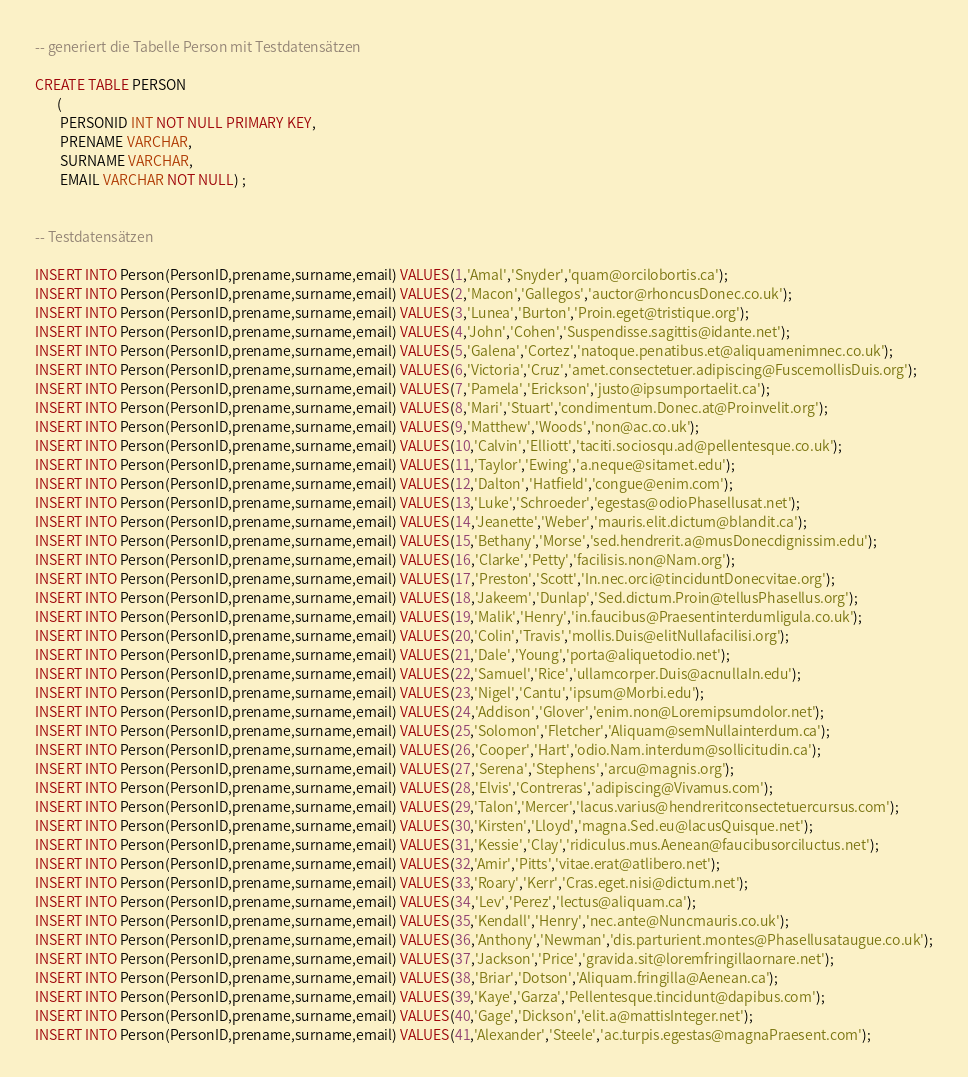Convert code to text. <code><loc_0><loc_0><loc_500><loc_500><_SQL_>-- generiert die Tabelle Person mit Testdatensätzen

CREATE TABLE PERSON
       (
		PERSONID INT NOT NULL PRIMARY KEY,
		PRENAME VARCHAR,
		SURNAME VARCHAR,
		EMAIL VARCHAR NOT NULL) ;
		

-- Testdatensätzen

INSERT INTO Person(PersonID,prename,surname,email) VALUES(1,'Amal','Snyder','quam@orcilobortis.ca');
INSERT INTO Person(PersonID,prename,surname,email) VALUES(2,'Macon','Gallegos','auctor@rhoncusDonec.co.uk');
INSERT INTO Person(PersonID,prename,surname,email) VALUES(3,'Lunea','Burton','Proin.eget@tristique.org');
INSERT INTO Person(PersonID,prename,surname,email) VALUES(4,'John','Cohen','Suspendisse.sagittis@idante.net');
INSERT INTO Person(PersonID,prename,surname,email) VALUES(5,'Galena','Cortez','natoque.penatibus.et@aliquamenimnec.co.uk');
INSERT INTO Person(PersonID,prename,surname,email) VALUES(6,'Victoria','Cruz','amet.consectetuer.adipiscing@FuscemollisDuis.org');
INSERT INTO Person(PersonID,prename,surname,email) VALUES(7,'Pamela','Erickson','justo@ipsumportaelit.ca');
INSERT INTO Person(PersonID,prename,surname,email) VALUES(8,'Mari','Stuart','condimentum.Donec.at@Proinvelit.org');
INSERT INTO Person(PersonID,prename,surname,email) VALUES(9,'Matthew','Woods','non@ac.co.uk');
INSERT INTO Person(PersonID,prename,surname,email) VALUES(10,'Calvin','Elliott','taciti.sociosqu.ad@pellentesque.co.uk');
INSERT INTO Person(PersonID,prename,surname,email) VALUES(11,'Taylor','Ewing','a.neque@sitamet.edu');
INSERT INTO Person(PersonID,prename,surname,email) VALUES(12,'Dalton','Hatfield','congue@enim.com');
INSERT INTO Person(PersonID,prename,surname,email) VALUES(13,'Luke','Schroeder','egestas@odioPhasellusat.net');
INSERT INTO Person(PersonID,prename,surname,email) VALUES(14,'Jeanette','Weber','mauris.elit.dictum@blandit.ca');
INSERT INTO Person(PersonID,prename,surname,email) VALUES(15,'Bethany','Morse','sed.hendrerit.a@musDonecdignissim.edu');
INSERT INTO Person(PersonID,prename,surname,email) VALUES(16,'Clarke','Petty','facilisis.non@Nam.org');
INSERT INTO Person(PersonID,prename,surname,email) VALUES(17,'Preston','Scott','In.nec.orci@tinciduntDonecvitae.org');
INSERT INTO Person(PersonID,prename,surname,email) VALUES(18,'Jakeem','Dunlap','Sed.dictum.Proin@tellusPhasellus.org');
INSERT INTO Person(PersonID,prename,surname,email) VALUES(19,'Malik','Henry','in.faucibus@Praesentinterdumligula.co.uk');
INSERT INTO Person(PersonID,prename,surname,email) VALUES(20,'Colin','Travis','mollis.Duis@elitNullafacilisi.org');
INSERT INTO Person(PersonID,prename,surname,email) VALUES(21,'Dale','Young','porta@aliquetodio.net');
INSERT INTO Person(PersonID,prename,surname,email) VALUES(22,'Samuel','Rice','ullamcorper.Duis@acnullaIn.edu');
INSERT INTO Person(PersonID,prename,surname,email) VALUES(23,'Nigel','Cantu','ipsum@Morbi.edu');
INSERT INTO Person(PersonID,prename,surname,email) VALUES(24,'Addison','Glover','enim.non@Loremipsumdolor.net');
INSERT INTO Person(PersonID,prename,surname,email) VALUES(25,'Solomon','Fletcher','Aliquam@semNullainterdum.ca');
INSERT INTO Person(PersonID,prename,surname,email) VALUES(26,'Cooper','Hart','odio.Nam.interdum@sollicitudin.ca');
INSERT INTO Person(PersonID,prename,surname,email) VALUES(27,'Serena','Stephens','arcu@magnis.org');
INSERT INTO Person(PersonID,prename,surname,email) VALUES(28,'Elvis','Contreras','adipiscing@Vivamus.com');
INSERT INTO Person(PersonID,prename,surname,email) VALUES(29,'Talon','Mercer','lacus.varius@hendreritconsectetuercursus.com');
INSERT INTO Person(PersonID,prename,surname,email) VALUES(30,'Kirsten','Lloyd','magna.Sed.eu@lacusQuisque.net');
INSERT INTO Person(PersonID,prename,surname,email) VALUES(31,'Kessie','Clay','ridiculus.mus.Aenean@faucibusorciluctus.net');
INSERT INTO Person(PersonID,prename,surname,email) VALUES(32,'Amir','Pitts','vitae.erat@atlibero.net');
INSERT INTO Person(PersonID,prename,surname,email) VALUES(33,'Roary','Kerr','Cras.eget.nisi@dictum.net');
INSERT INTO Person(PersonID,prename,surname,email) VALUES(34,'Lev','Perez','lectus@aliquam.ca');
INSERT INTO Person(PersonID,prename,surname,email) VALUES(35,'Kendall','Henry','nec.ante@Nuncmauris.co.uk');
INSERT INTO Person(PersonID,prename,surname,email) VALUES(36,'Anthony','Newman','dis.parturient.montes@Phasellusataugue.co.uk');
INSERT INTO Person(PersonID,prename,surname,email) VALUES(37,'Jackson','Price','gravida.sit@loremfringillaornare.net');
INSERT INTO Person(PersonID,prename,surname,email) VALUES(38,'Briar','Dotson','Aliquam.fringilla@Aenean.ca');
INSERT INTO Person(PersonID,prename,surname,email) VALUES(39,'Kaye','Garza','Pellentesque.tincidunt@dapibus.com');
INSERT INTO Person(PersonID,prename,surname,email) VALUES(40,'Gage','Dickson','elit.a@mattisInteger.net');
INSERT INTO Person(PersonID,prename,surname,email) VALUES(41,'Alexander','Steele','ac.turpis.egestas@magnaPraesent.com');</code> 